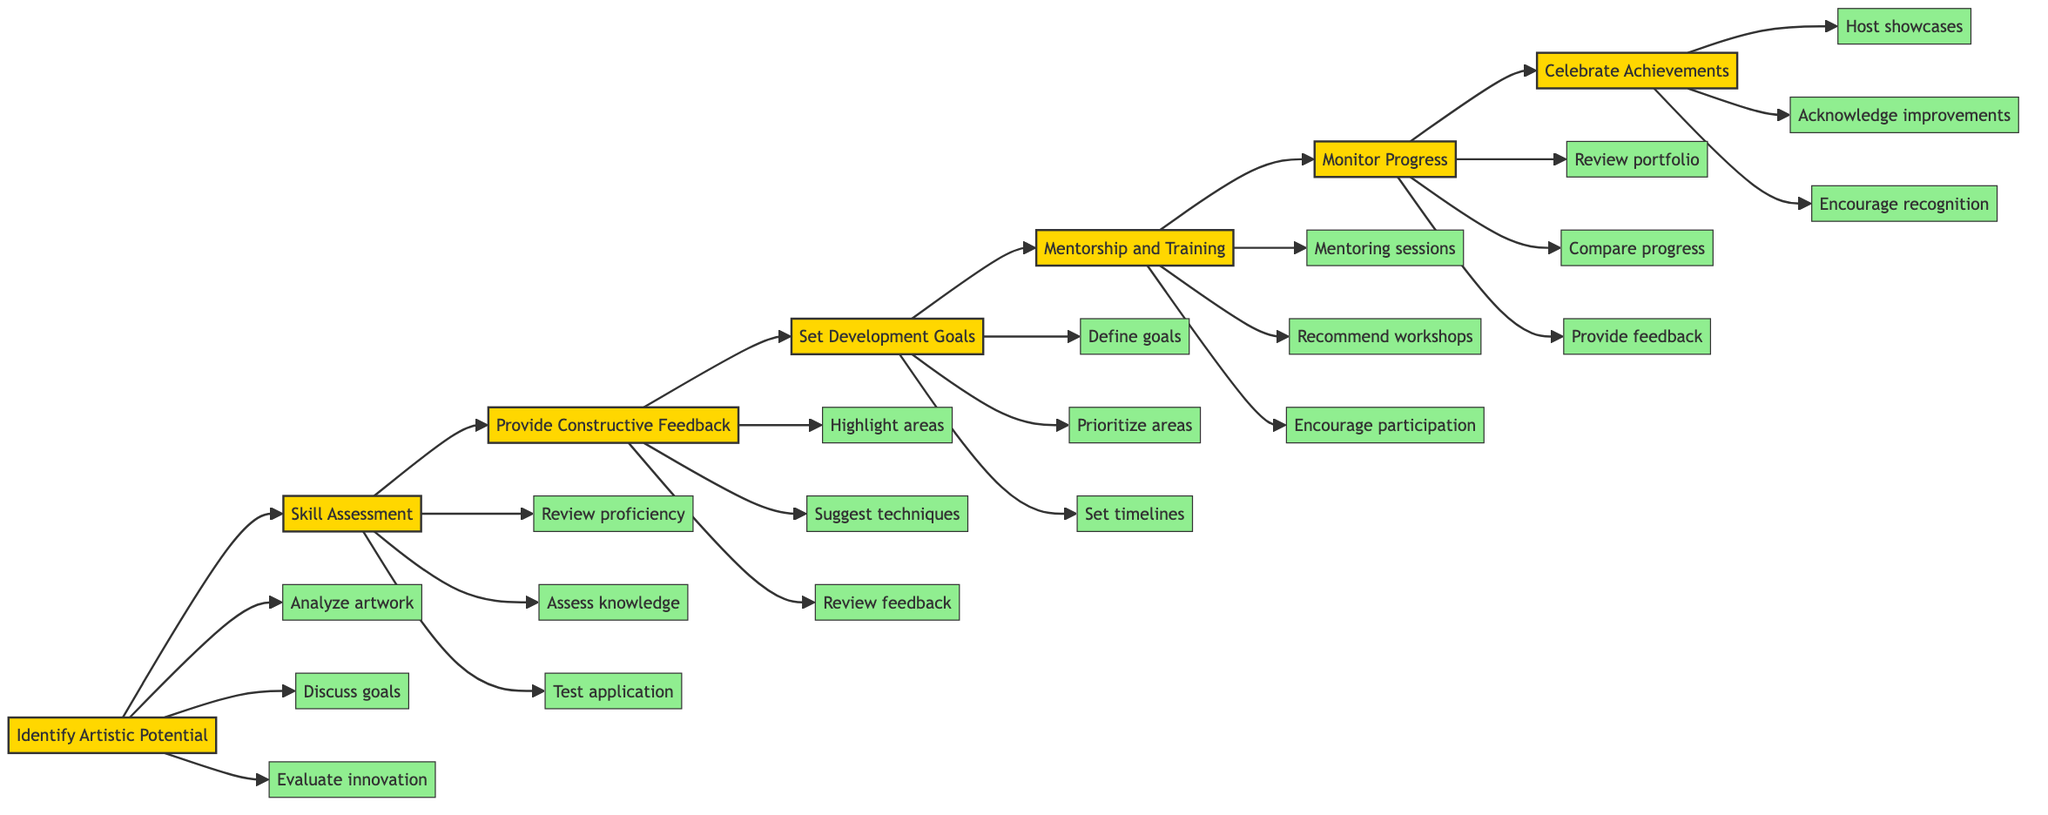What is the first step in the flowchart? The first step in the flowchart is "Identify Artistic Potential," which is denoted as A.
Answer: Identify Artistic Potential How many actions are associated with "Skill Assessment"? Under "Skill Assessment," represented by B, there are three actions: Review proficiency, Assess knowledge, and Test application.
Answer: Three What comes after "Provide Constructive Feedback"? Following "Provide Constructive Feedback," represented by C, the next step is "Set Development Goals," denoted as D.
Answer: Set Development Goals Which step focuses on creating a roadmap for growth? The step that focuses on creating a roadmap for growth is "Set Development Goals," which indicates planning for the artist's development.
Answer: Set Development Goals What are the actions listed under "Celebrate Achievements"? The actions under "Celebrate Achievements," represented by G, include Host showcases, Acknowledge improvements, and Encourage recognition.
Answer: Host showcases, Acknowledge improvements, Encourage recognition What are the three actions that support "Mentorship and Training"? The three actions supporting "Mentorship and Training," denoted by E, are: Organize mentoring sessions, Recommend workshops, and Encourage participation.
Answer: Organize mentoring sessions, Recommend workshops, Encourage participation How many total steps are there in the diagram? There are seven steps in the diagram, starting from "Identify Artistic Potential" to "Celebrate Achievements."
Answer: Seven What is the last step in the flowchart? The last step in the flowchart is "Celebrate Achievements," represented by G.
Answer: Celebrate Achievements 